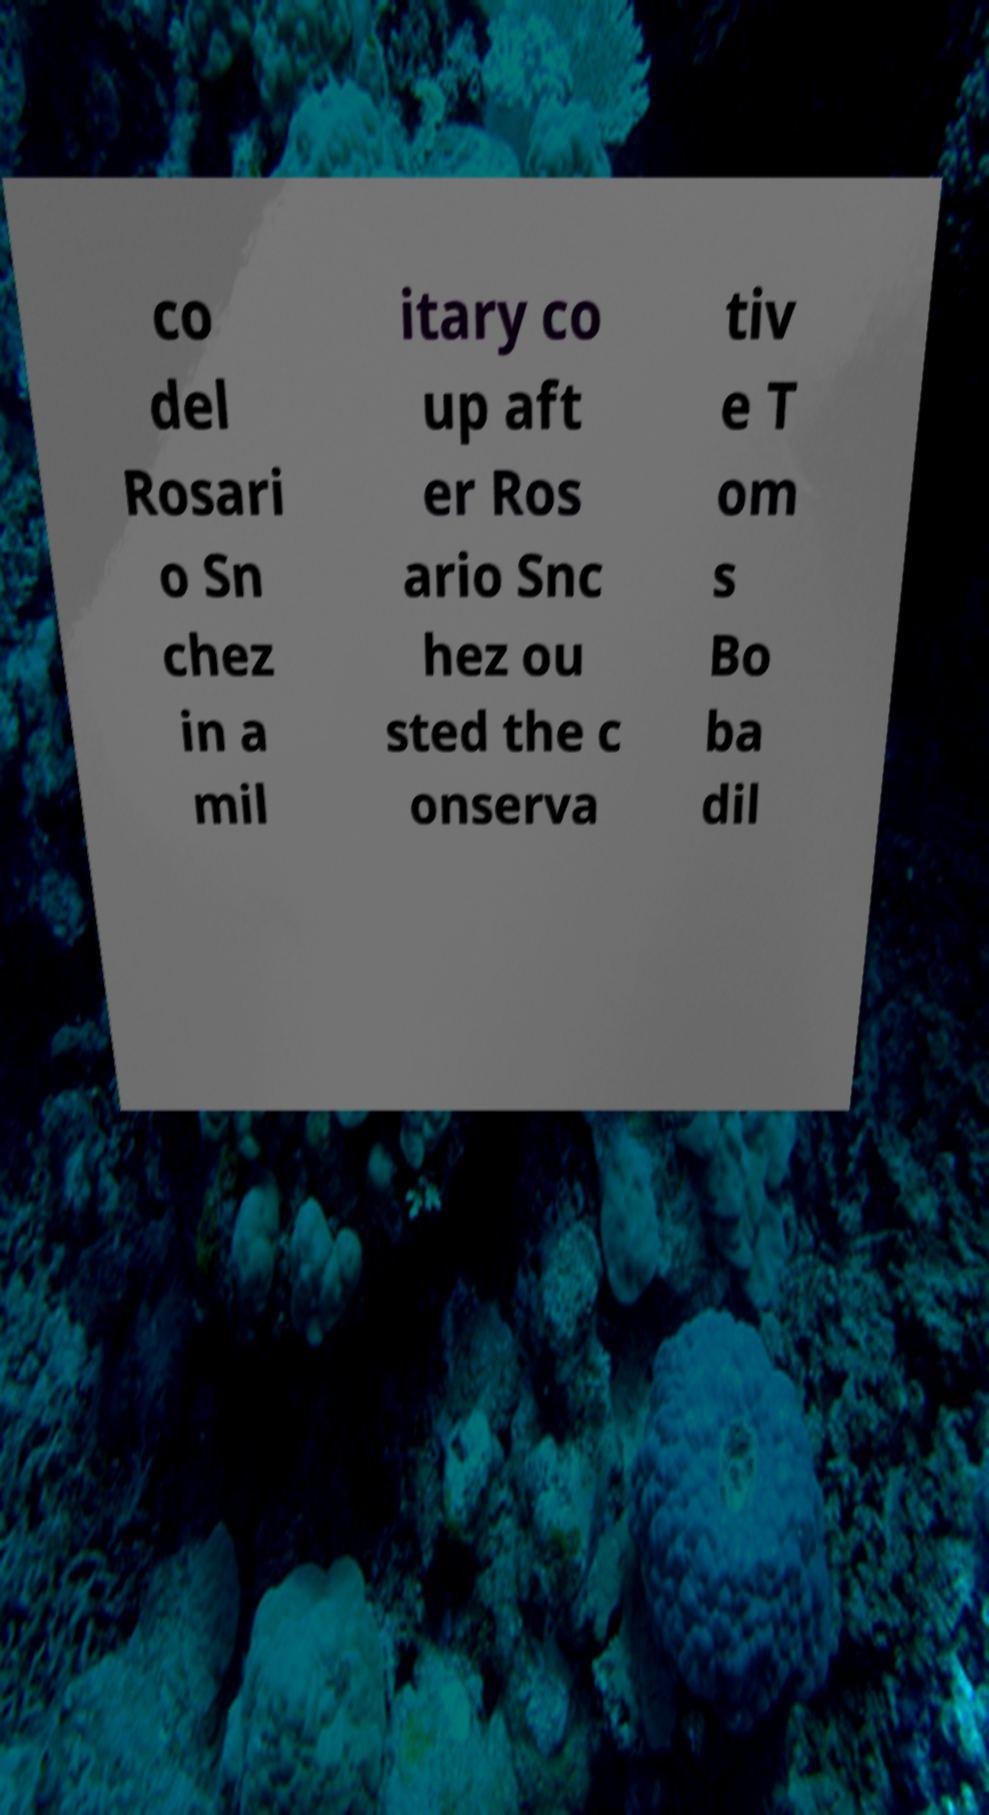Can you read and provide the text displayed in the image?This photo seems to have some interesting text. Can you extract and type it out for me? co del Rosari o Sn chez in a mil itary co up aft er Ros ario Snc hez ou sted the c onserva tiv e T om s Bo ba dil 